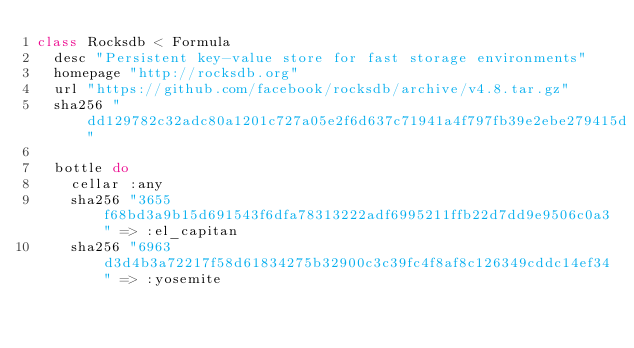Convert code to text. <code><loc_0><loc_0><loc_500><loc_500><_Ruby_>class Rocksdb < Formula
  desc "Persistent key-value store for fast storage environments"
  homepage "http://rocksdb.org"
  url "https://github.com/facebook/rocksdb/archive/v4.8.tar.gz"
  sha256 "dd129782c32adc80a1201c727a05e2f6d637c71941a4f797fb39e2ebe279415d"

  bottle do
    cellar :any
    sha256 "3655f68bd3a9b15d691543f6dfa78313222adf6995211ffb22d7dd9e9506c0a3" => :el_capitan
    sha256 "6963d3d4b3a72217f58d61834275b32900c3c39fc4f8af8c126349cddc14ef34" => :yosemite</code> 